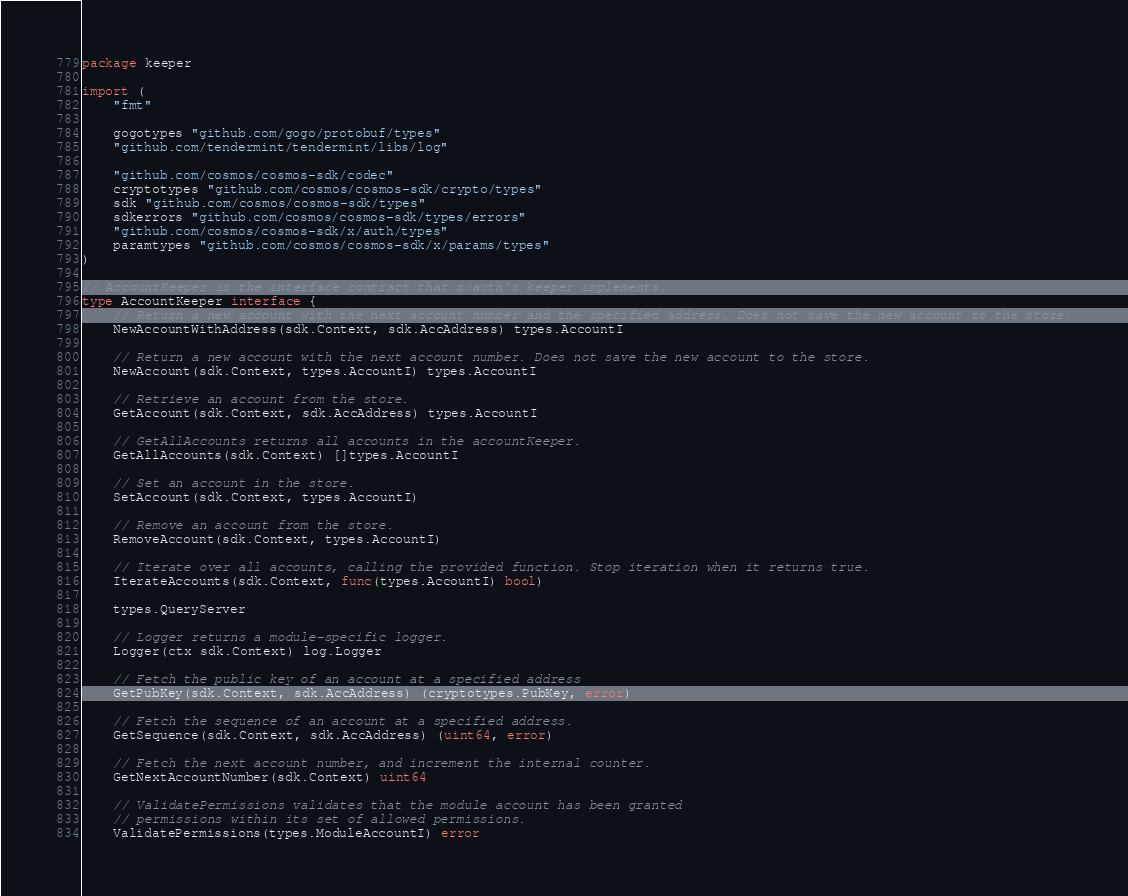<code> <loc_0><loc_0><loc_500><loc_500><_Go_>package keeper

import (
	"fmt"

	gogotypes "github.com/gogo/protobuf/types"
	"github.com/tendermint/tendermint/libs/log"

	"github.com/cosmos/cosmos-sdk/codec"
	cryptotypes "github.com/cosmos/cosmos-sdk/crypto/types"
	sdk "github.com/cosmos/cosmos-sdk/types"
	sdkerrors "github.com/cosmos/cosmos-sdk/types/errors"
	"github.com/cosmos/cosmos-sdk/x/auth/types"
	paramtypes "github.com/cosmos/cosmos-sdk/x/params/types"
)

// AccountKeeper is the interface contract that x/auth's keeper implements.
type AccountKeeper interface {
	// Return a new account with the next account number and the specified address. Does not save the new account to the store.
	NewAccountWithAddress(sdk.Context, sdk.AccAddress) types.AccountI

	// Return a new account with the next account number. Does not save the new account to the store.
	NewAccount(sdk.Context, types.AccountI) types.AccountI

	// Retrieve an account from the store.
	GetAccount(sdk.Context, sdk.AccAddress) types.AccountI

	// GetAllAccounts returns all accounts in the accountKeeper.
	GetAllAccounts(sdk.Context) []types.AccountI

	// Set an account in the store.
	SetAccount(sdk.Context, types.AccountI)

	// Remove an account from the store.
	RemoveAccount(sdk.Context, types.AccountI)

	// Iterate over all accounts, calling the provided function. Stop iteration when it returns true.
	IterateAccounts(sdk.Context, func(types.AccountI) bool)

	types.QueryServer

	// Logger returns a module-specific logger.
	Logger(ctx sdk.Context) log.Logger

	// Fetch the public key of an account at a specified address
	GetPubKey(sdk.Context, sdk.AccAddress) (cryptotypes.PubKey, error)

	// Fetch the sequence of an account at a specified address.
	GetSequence(sdk.Context, sdk.AccAddress) (uint64, error)

	// Fetch the next account number, and increment the internal counter.
	GetNextAccountNumber(sdk.Context) uint64

	// ValidatePermissions validates that the module account has been granted
	// permissions within its set of allowed permissions.
	ValidatePermissions(types.ModuleAccountI) error
</code> 